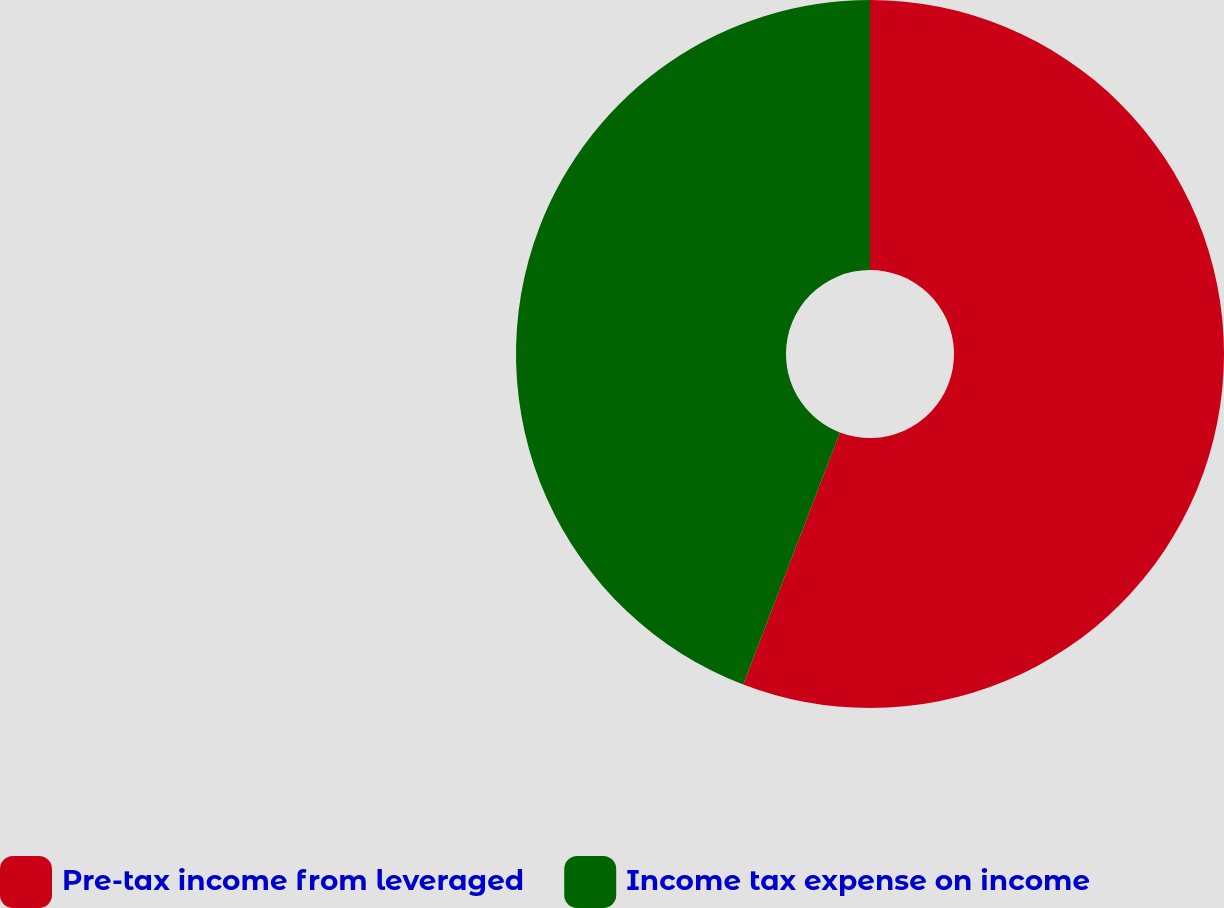Convert chart to OTSL. <chart><loc_0><loc_0><loc_500><loc_500><pie_chart><fcel>Pre-tax income from leveraged<fcel>Income tax expense on income<nl><fcel>55.83%<fcel>44.17%<nl></chart> 